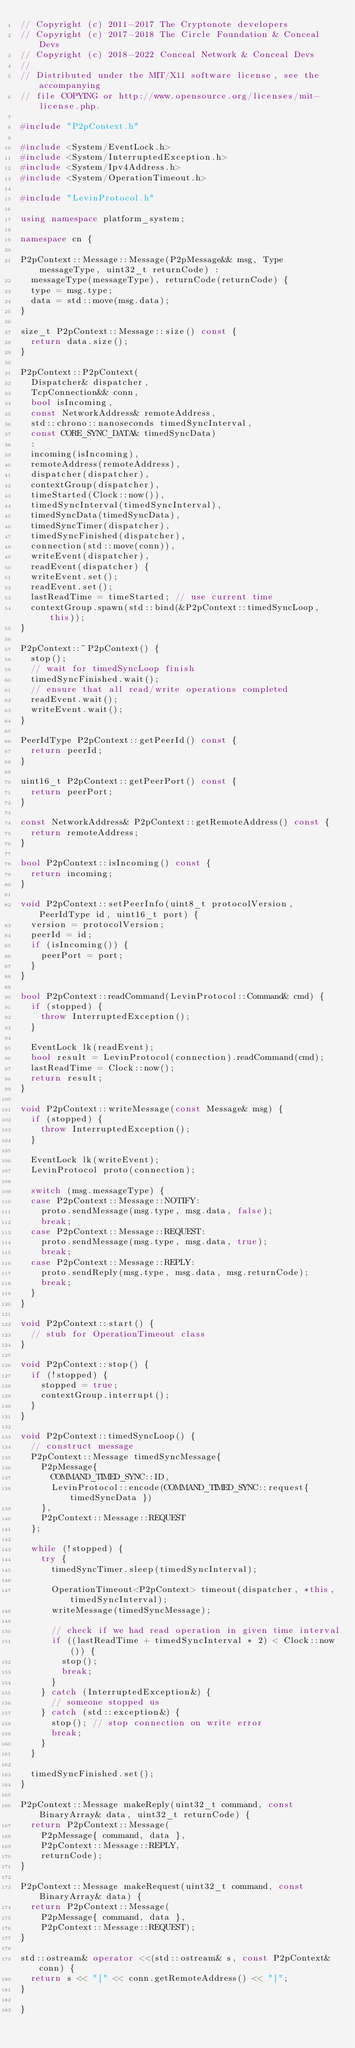<code> <loc_0><loc_0><loc_500><loc_500><_C++_>// Copyright (c) 2011-2017 The Cryptonote developers
// Copyright (c) 2017-2018 The Circle Foundation & Conceal Devs
// Copyright (c) 2018-2022 Conceal Network & Conceal Devs
//
// Distributed under the MIT/X11 software license, see the accompanying
// file COPYING or http://www.opensource.org/licenses/mit-license.php.

#include "P2pContext.h"

#include <System/EventLock.h>
#include <System/InterruptedException.h>
#include <System/Ipv4Address.h>
#include <System/OperationTimeout.h>

#include "LevinProtocol.h"

using namespace platform_system;

namespace cn {

P2pContext::Message::Message(P2pMessage&& msg, Type messageType, uint32_t returnCode) :
  messageType(messageType), returnCode(returnCode) {
  type = msg.type;
  data = std::move(msg.data);
}

size_t P2pContext::Message::size() const {
  return data.size();
}

P2pContext::P2pContext(
  Dispatcher& dispatcher,
  TcpConnection&& conn,
  bool isIncoming,
  const NetworkAddress& remoteAddress,
  std::chrono::nanoseconds timedSyncInterval,
  const CORE_SYNC_DATA& timedSyncData)
  :
  incoming(isIncoming),
  remoteAddress(remoteAddress),
  dispatcher(dispatcher),
  contextGroup(dispatcher),
  timeStarted(Clock::now()),
  timedSyncInterval(timedSyncInterval),
  timedSyncData(timedSyncData),
  timedSyncTimer(dispatcher),
  timedSyncFinished(dispatcher),
  connection(std::move(conn)),
  writeEvent(dispatcher),
  readEvent(dispatcher) {
  writeEvent.set();
  readEvent.set();
  lastReadTime = timeStarted; // use current time
  contextGroup.spawn(std::bind(&P2pContext::timedSyncLoop, this));
}

P2pContext::~P2pContext() {
  stop();
  // wait for timedSyncLoop finish
  timedSyncFinished.wait();
  // ensure that all read/write operations completed
  readEvent.wait();
  writeEvent.wait();
}

PeerIdType P2pContext::getPeerId() const {
  return peerId;
}

uint16_t P2pContext::getPeerPort() const {
  return peerPort;
}

const NetworkAddress& P2pContext::getRemoteAddress() const {
  return remoteAddress;
}

bool P2pContext::isIncoming() const {
  return incoming;
}

void P2pContext::setPeerInfo(uint8_t protocolVersion, PeerIdType id, uint16_t port) {
  version = protocolVersion;
  peerId = id;
  if (isIncoming()) {
    peerPort = port;
  }
}

bool P2pContext::readCommand(LevinProtocol::Command& cmd) {
  if (stopped) {
    throw InterruptedException();
  }

  EventLock lk(readEvent);
  bool result = LevinProtocol(connection).readCommand(cmd);
  lastReadTime = Clock::now();
  return result;
}

void P2pContext::writeMessage(const Message& msg) {
  if (stopped) {
    throw InterruptedException();
  }

  EventLock lk(writeEvent);
  LevinProtocol proto(connection);

  switch (msg.messageType) {
  case P2pContext::Message::NOTIFY:
    proto.sendMessage(msg.type, msg.data, false);
    break;
  case P2pContext::Message::REQUEST:
    proto.sendMessage(msg.type, msg.data, true);
    break;
  case P2pContext::Message::REPLY:
    proto.sendReply(msg.type, msg.data, msg.returnCode);
    break;
  }
}

void P2pContext::start() {
  // stub for OperationTimeout class
} 

void P2pContext::stop() {
  if (!stopped) {
    stopped = true;
    contextGroup.interrupt();
  }
}

void P2pContext::timedSyncLoop() {
  // construct message
  P2pContext::Message timedSyncMessage{ 
    P2pMessage{ 
      COMMAND_TIMED_SYNC::ID, 
      LevinProtocol::encode(COMMAND_TIMED_SYNC::request{ timedSyncData })
    }, 
    P2pContext::Message::REQUEST 
  };

  while (!stopped) {
    try {
      timedSyncTimer.sleep(timedSyncInterval);

      OperationTimeout<P2pContext> timeout(dispatcher, *this, timedSyncInterval);
      writeMessage(timedSyncMessage);

      // check if we had read operation in given time interval
      if ((lastReadTime + timedSyncInterval * 2) < Clock::now()) {
        stop();
        break;
      }
    } catch (InterruptedException&) {
      // someone stopped us
    } catch (std::exception&) {
      stop(); // stop connection on write error
      break;
    }
  }

  timedSyncFinished.set();
}

P2pContext::Message makeReply(uint32_t command, const BinaryArray& data, uint32_t returnCode) {
  return P2pContext::Message(
    P2pMessage{ command, data },
    P2pContext::Message::REPLY,
    returnCode);
}

P2pContext::Message makeRequest(uint32_t command, const BinaryArray& data) {
  return P2pContext::Message(
    P2pMessage{ command, data },
    P2pContext::Message::REQUEST);
}

std::ostream& operator <<(std::ostream& s, const P2pContext& conn) {
  return s << "[" << conn.getRemoteAddress() << "]";
}

}
</code> 